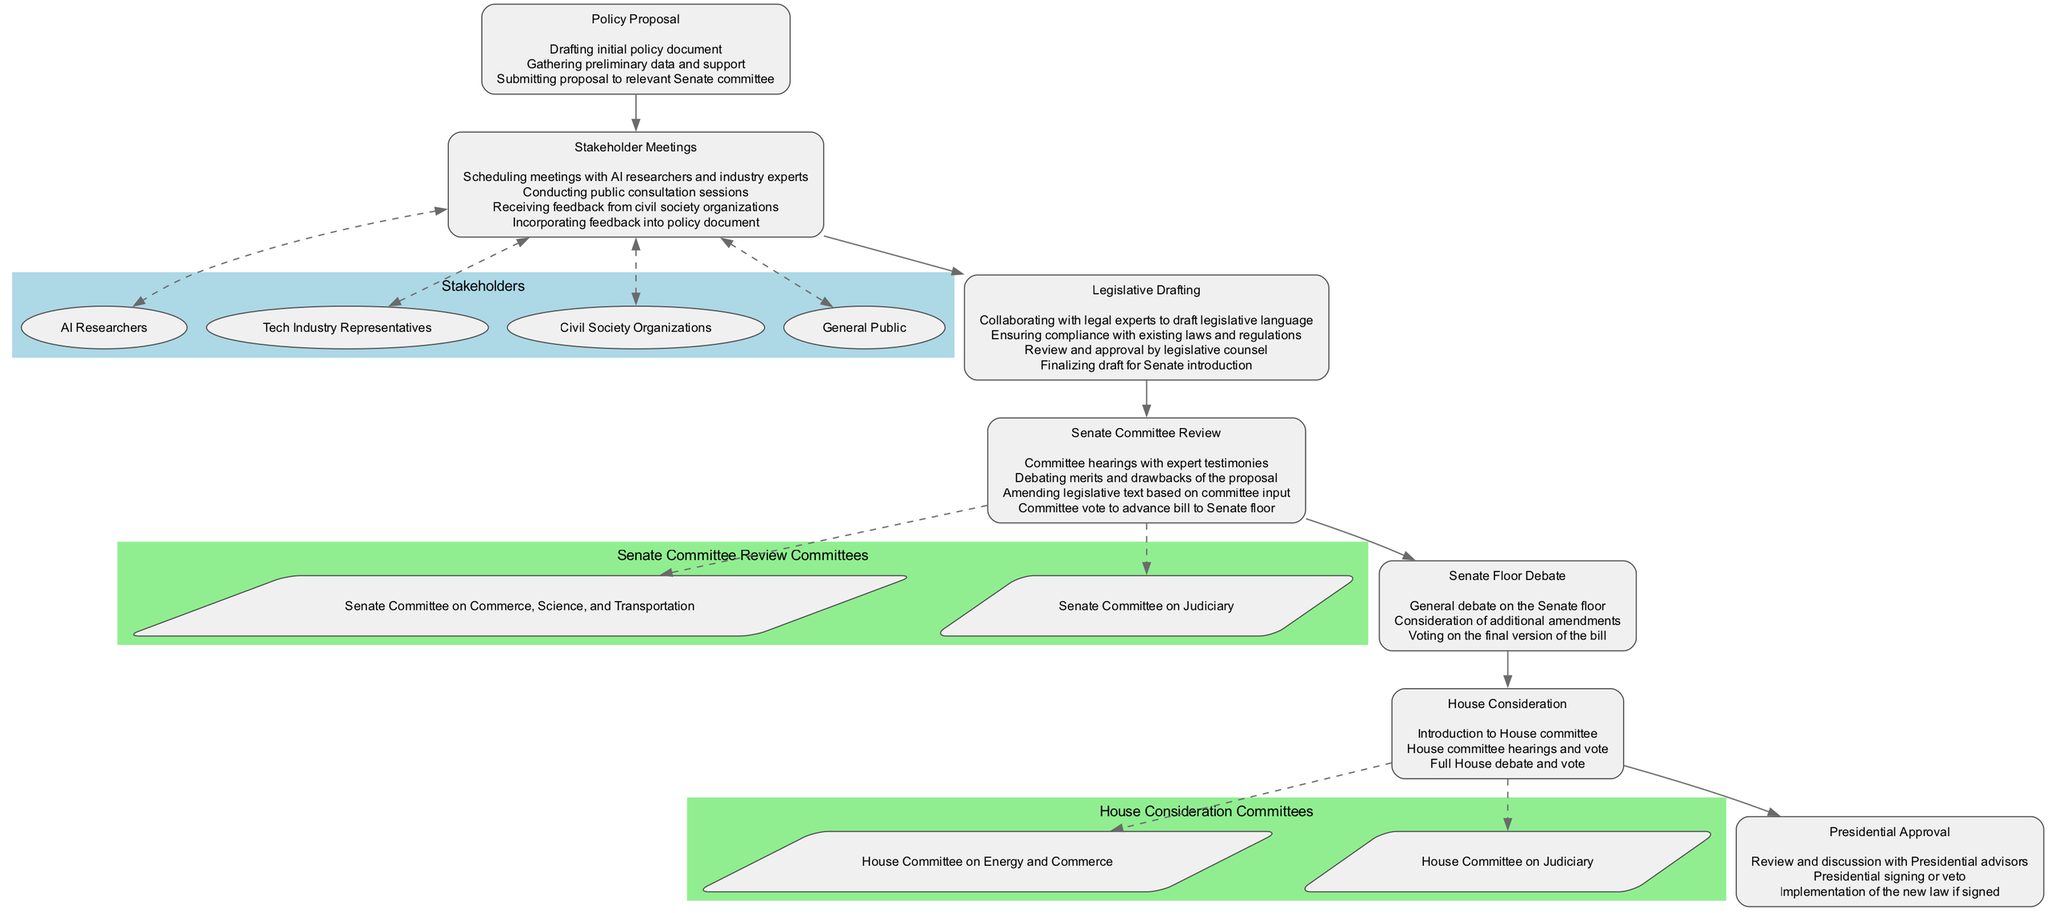What is the first step in the AI Policy Development Workflow? The first step listed in the workflow is "Drafting initial policy document," which is part of the "Policy Proposal" stage.
Answer: Drafting initial policy document How many stakeholders are involved in the Stakeholder Meetings? The diagram lists four stakeholders: AI Researchers, Tech Industry Representatives, Civil Society Organizations, and General Public.
Answer: Four What committees are involved during the Senate Committee Review? The Senate Committee Review involves two committees: Senate Committee on Commerce, Science, and Transportation and Senate Committee on Judiciary.
Answer: Senate Committee on Commerce, Science, and Transportation; Senate Committee on Judiciary Which step follows the Stakeholder Meetings in the workflow? After Stakeholder Meetings, the next step is "Legislative Drafting," which prepares the legislative text based on inputs gathered.
Answer: Legislative Drafting What action is taken after the House Committee hearings? Following the House Committee hearings, there is a "Full House debate and vote" that evaluates the bill.
Answer: Full House debate and vote Which phase includes a "Committee vote to advance bill to Senate floor"? This action occurs during the "Senate Committee Review" phase, emphasizing the committee's assessment of the proposal.
Answer: Senate Committee Review What happens during the Presidential Approval phase? In this phase, the President reviews the bill, discusses it with advisors, and then either signs or vetoes the proposed law.
Answer: Review and discussion with Presidential advisors What is the last stage in the AI Policy Development Workflow? The last stage is "Presidential Approval," where the final action of signing the bill into law occurs.
Answer: Presidential Approval How many key steps are listed under the Senate Floor Debate? There are three key steps listed: General debate on the Senate floor, Consideration of additional amendments, and Voting on the final version of the bill.
Answer: Three 